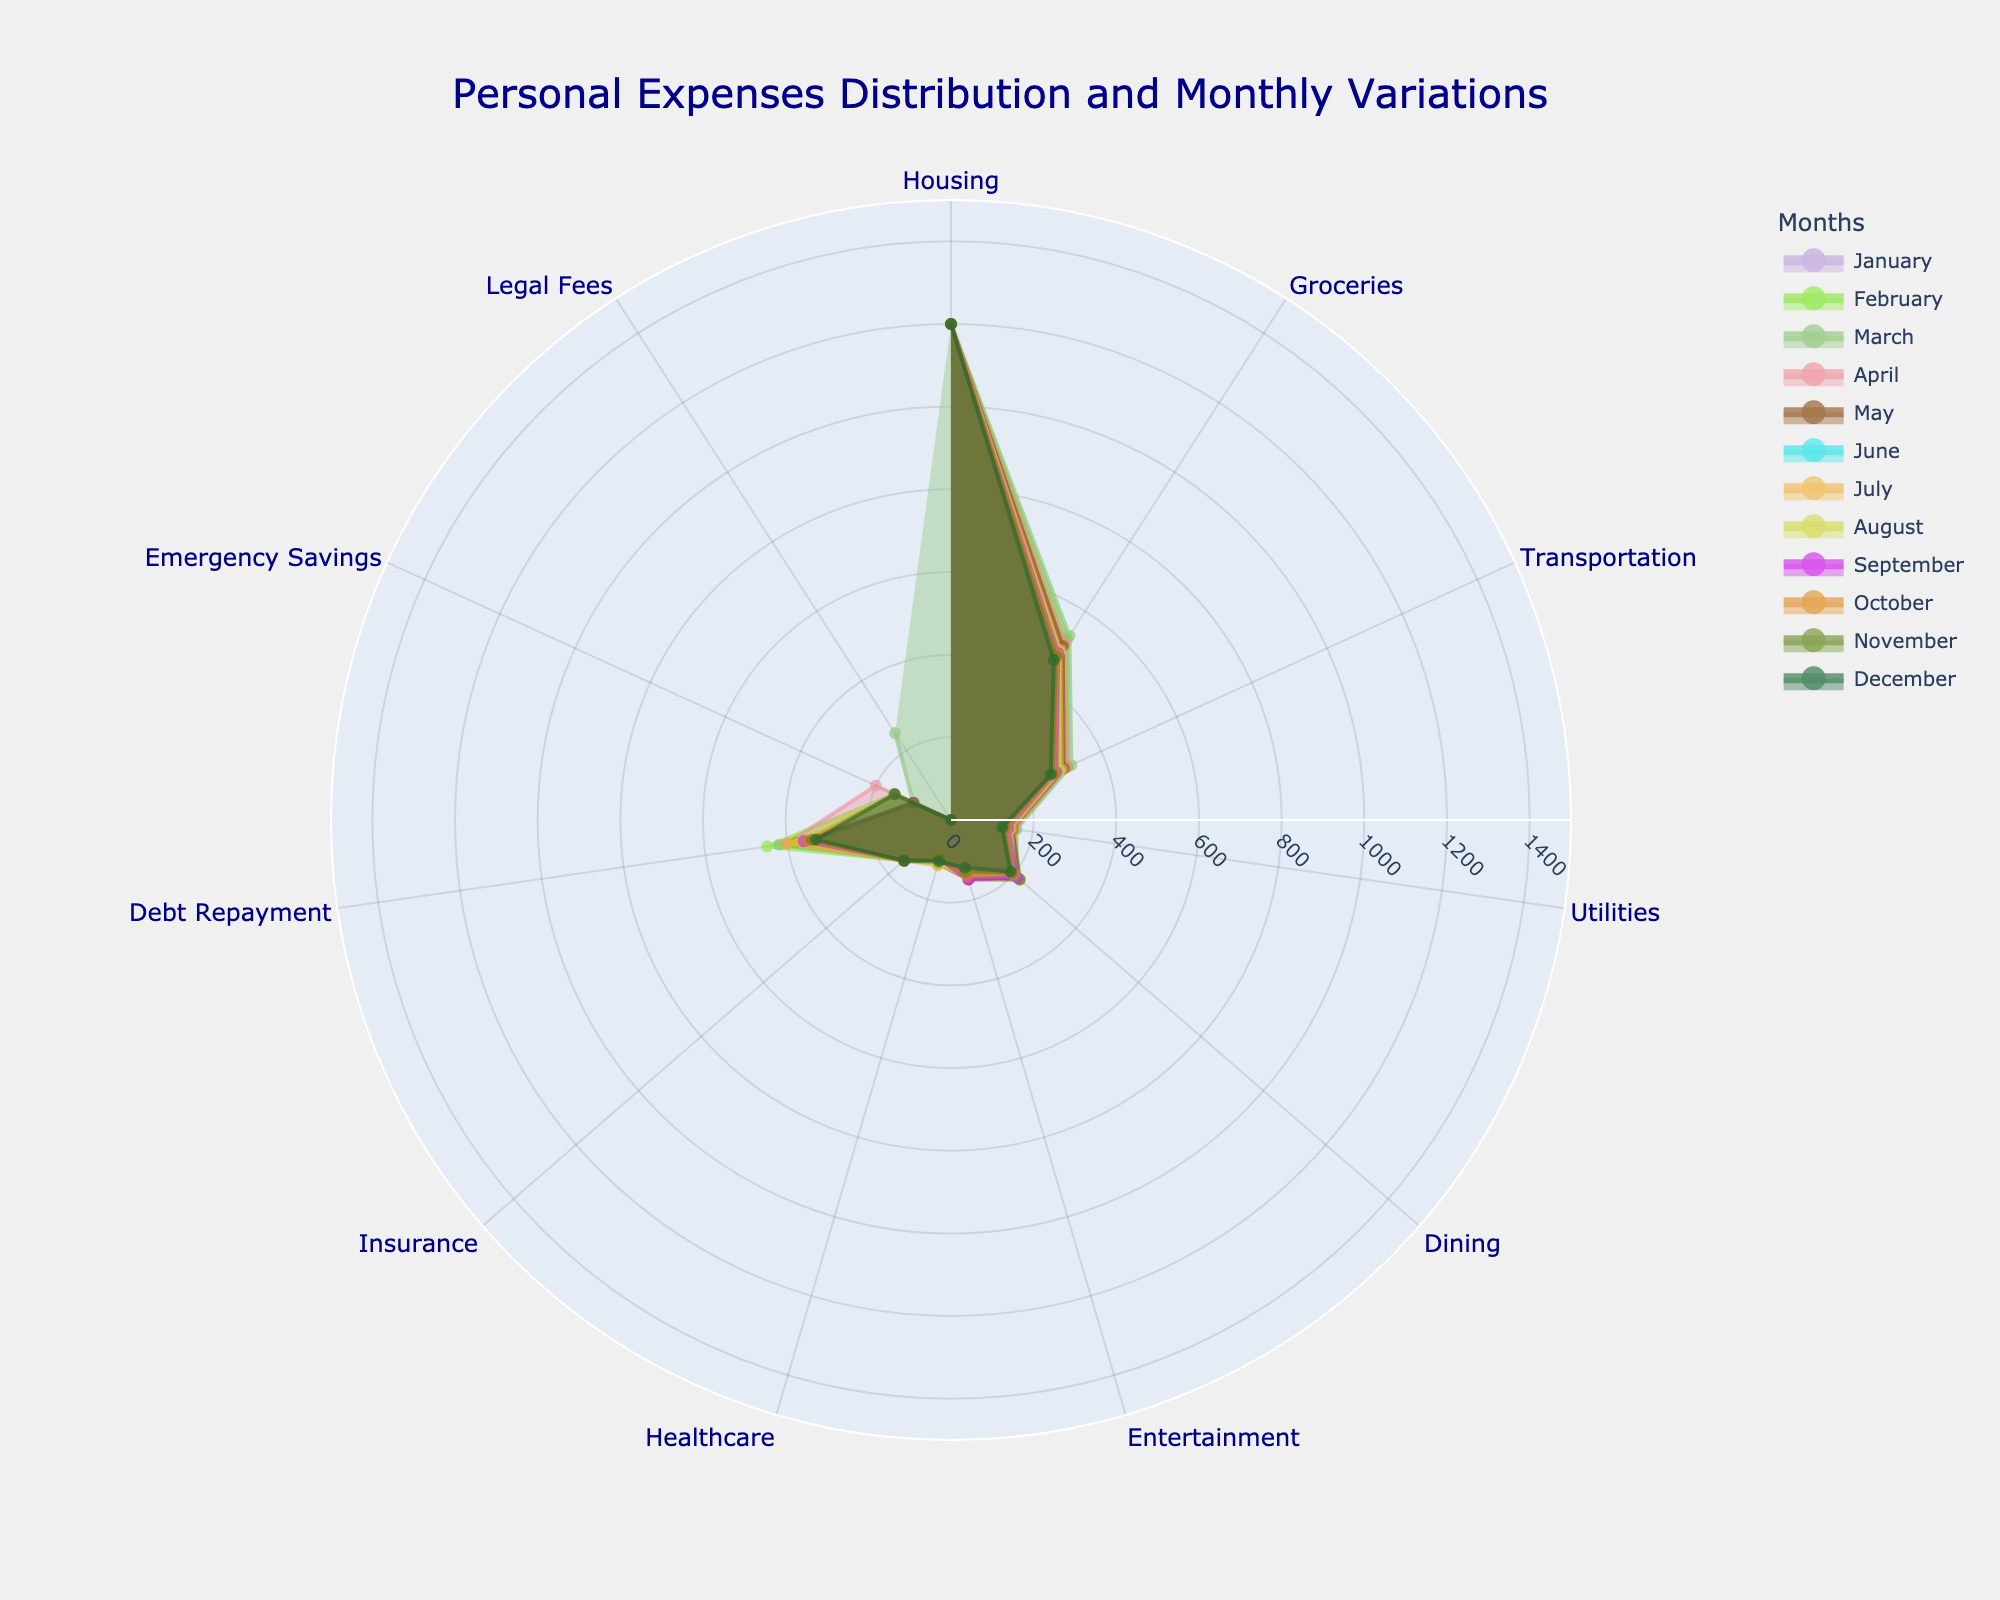What is the title of the plot? The title of the plot is located at the top and reads "Personal Expenses Distribution and Monthly Variations." This provides a summary of what the plot is about—specifically the distribution and variation of personal expenses over months.
Answer: Personal Expenses Distribution and Monthly Variations How many categories are shown in the Polar Chart? To determine the number of categories, count each distinct label along the angular axis. Each label corresponds to a type of expense, such as Housing, Groceries, Transportation, etc.
Answer: 11 Which category has the highest consistent expense throughout the year? The category with the highest consistent expense throughout the year is the one whose values are the highest for every plotted month. Observing each month distinctly, you'll notice the Housing category consistently has the highest values.
Answer: Housing Which category shows the most fluctuation throughout the year in terms of expenses? To identify the category with the most fluctuation, observe the extent of changes in the plotted values from month to month. Legal Fees has the most fluctuation because they vary significantly (most months have 0, but there's a peak in March).
Answer: Legal Fees What is the general trend in Transportation expenses from January to December? To determine the trend, look at how the values for Transportation change over the months. The values start high and gradually decrease over the months.
Answer: Decreasing What is the difference between the highest and lowest values in Groceries expenses for the year? To find the difference, locate the maximum and minimum values for Groceries across all months. The highest value is 530 in March, and the lowest is 460 in December. The difference is 530 - 460.
Answer: 70 Which month has the peak expense in Debt Repayment category? To find the peak expense month, observe which month's plot line shows the highest value for the Debt Repayment category. The peak value is in February.
Answer: February Compare the expense trends of Utilities and Dining throughout the year. How are they similar or different? To compare, observe the pattern of values for both Utilities and Dining across all months. Both categories have a decreasing trend, but Dining has more fluctuations with some increases, while Utilities steadily decrease.
Answer: Similar in trend (decreasing), different in fluctuations (Dining has more) What category has the lowest average expense over the year? To find the category with the lowest average, sum up the values for each category across the months and divide by 12. Legal Fees has most months with 0 and just one peak, leading to the lowest average.
Answer: Legal Fees How do Emergency Savings expenses change over the year? To identify the change, look at the values for Emergency Savings month by month. The expenses alternate between 100 and 150 throughout the year.
Answer: Alternating 